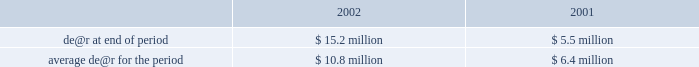Entergy corporation and subsidiaries management's financial discussion and analysis annually , beginning in 2006 , if power market prices drop below the ppa prices .
Accordingly , because the price is not fixed , the table above does not report power from that plant as sold forward after 2005 .
Under the ppas with nypa for the output of power from indian point 3 and fitzpatrick , the non-utility nuclear business is obligated to produce at an average capacity factor of 85% ( 85 % ) with a financial true-up payment to nypa should nypa's cost to purchase power due to an output shortfall be higher than the ppas' price .
The calculation of any true-up payments is based on two two-year periods .
For the first period , which ran through november 20 , 2002 , indian point 3 and fitzpatrick operated at 95% ( 95 % ) and 97% ( 97 % ) , respectively , under the true-up formula .
Credits of up to 5% ( 5 % ) reflecting period one generation above 85% ( 85 % ) can be used to offset any output shortfalls in the second period , which runs through the end of the ppas on december 31 , 2004 .
Entergy continually monitors industry trends in order to determine whether asset impairments or other losses could result from a decline in value , or cancellation , of merchant power projects , and records provisions for impairments and losses accordingly .
Marketing and trading the earnings of entergy's energy commodity services segment are exposed to commodity price market risks primarily through entergy's 50%-owned , unconsolidated investment in entergy-koch .
Entergy-koch trading ( ekt ) uses value-at-risk models as one measure of the market risk of a loss in fair value for ekt's natural gas and power trading portfolio .
Actual future gains and losses in portfolios will differ from those estimated based upon actual fluctuations in market rates , operating exposures , and the timing thereof , and changes in the portfolio of derivative financial instruments during the year .
To manage its portfolio , ekt enters into various derivative and contractual transactions in accordance with the policy approved by the trading committee of the governing board of entergy-koch .
The trading portfolio consists of physical and financial natural gas and power as well as other energy and weather-related contracts .
These contracts take many forms , including futures , forwards , swaps , and options .
Characteristics of ekt's value-at-risk method and the use of that method are as follows : fffd value-at-risk is used in conjunction with stress testing , position reporting , and profit and loss reporting in order to measure and control the risk inherent in the trading and mark-to-market portfolios .
Fffd ekt estimates its value-at-risk using a model based on j.p .
Morgan's risk metrics methodology combined with a monte carlo simulation approach .
Fffd ekt estimates its daily value-at-risk for natural gas and power using a 97.5% ( 97.5 % ) confidence level .
Ekt's daily value-at-risk is a measure that indicates that , if prices moved against the positions , the loss in neutralizing the portfolio would not be expected to exceed the calculated value-at-risk .
Fffd ekt seeks to limit the daily value-at-risk on any given day to a certain dollar amount approved by the trading committee .
Ekt's value-at-risk measures , which it calls daily earnings at risk ( de@r ) , for its trading portfolio were as follows: .
Ekt's de@r increased in 2002 compared to 2001 as a result of an increase in the size of the position held and an increase in the volatility of natural gas prices in the latter part of the year .
For all derivative and contractual transactions , ekt is exposed to losses in the event of nonperformance by counterparties to these transactions .
Relevant considerations when assessing ekt's credit risk exposure include: .
What is the percent change in average daily earnings at risk for the period from 2001 to 2002? 
Computations: ((10.8 - 6.4) / 6.4)
Answer: 0.6875. Entergy corporation and subsidiaries management's financial discussion and analysis annually , beginning in 2006 , if power market prices drop below the ppa prices .
Accordingly , because the price is not fixed , the table above does not report power from that plant as sold forward after 2005 .
Under the ppas with nypa for the output of power from indian point 3 and fitzpatrick , the non-utility nuclear business is obligated to produce at an average capacity factor of 85% ( 85 % ) with a financial true-up payment to nypa should nypa's cost to purchase power due to an output shortfall be higher than the ppas' price .
The calculation of any true-up payments is based on two two-year periods .
For the first period , which ran through november 20 , 2002 , indian point 3 and fitzpatrick operated at 95% ( 95 % ) and 97% ( 97 % ) , respectively , under the true-up formula .
Credits of up to 5% ( 5 % ) reflecting period one generation above 85% ( 85 % ) can be used to offset any output shortfalls in the second period , which runs through the end of the ppas on december 31 , 2004 .
Entergy continually monitors industry trends in order to determine whether asset impairments or other losses could result from a decline in value , or cancellation , of merchant power projects , and records provisions for impairments and losses accordingly .
Marketing and trading the earnings of entergy's energy commodity services segment are exposed to commodity price market risks primarily through entergy's 50%-owned , unconsolidated investment in entergy-koch .
Entergy-koch trading ( ekt ) uses value-at-risk models as one measure of the market risk of a loss in fair value for ekt's natural gas and power trading portfolio .
Actual future gains and losses in portfolios will differ from those estimated based upon actual fluctuations in market rates , operating exposures , and the timing thereof , and changes in the portfolio of derivative financial instruments during the year .
To manage its portfolio , ekt enters into various derivative and contractual transactions in accordance with the policy approved by the trading committee of the governing board of entergy-koch .
The trading portfolio consists of physical and financial natural gas and power as well as other energy and weather-related contracts .
These contracts take many forms , including futures , forwards , swaps , and options .
Characteristics of ekt's value-at-risk method and the use of that method are as follows : fffd value-at-risk is used in conjunction with stress testing , position reporting , and profit and loss reporting in order to measure and control the risk inherent in the trading and mark-to-market portfolios .
Fffd ekt estimates its value-at-risk using a model based on j.p .
Morgan's risk metrics methodology combined with a monte carlo simulation approach .
Fffd ekt estimates its daily value-at-risk for natural gas and power using a 97.5% ( 97.5 % ) confidence level .
Ekt's daily value-at-risk is a measure that indicates that , if prices moved against the positions , the loss in neutralizing the portfolio would not be expected to exceed the calculated value-at-risk .
Fffd ekt seeks to limit the daily value-at-risk on any given day to a certain dollar amount approved by the trading committee .
Ekt's value-at-risk measures , which it calls daily earnings at risk ( de@r ) , for its trading portfolio were as follows: .
Ekt's de@r increased in 2002 compared to 2001 as a result of an increase in the size of the position held and an increase in the volatility of natural gas prices in the latter part of the year .
For all derivative and contractual transactions , ekt is exposed to losses in the event of nonperformance by counterparties to these transactions .
Relevant considerations when assessing ekt's credit risk exposure include: .
What is the percent change in daily earnings at risk at the end of the period from 2001 to 2002? 
Computations: ((15.2 - 5.5) / 5.5)
Answer: 1.76364. 